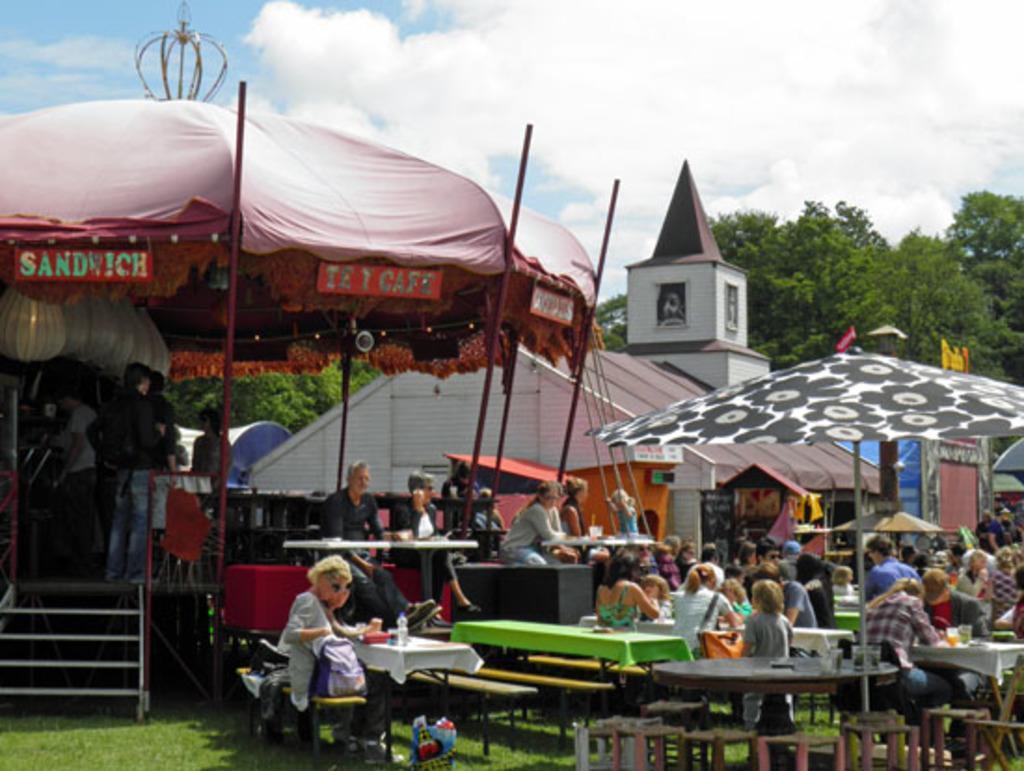Please provide a concise description of this image. In this image I can see number of people sitting on benches in front of tables, on the tables I can see bottles and boxes and glasses. In the background I can see a tent, a building, few trees, few people standing, the sky and clouds. 